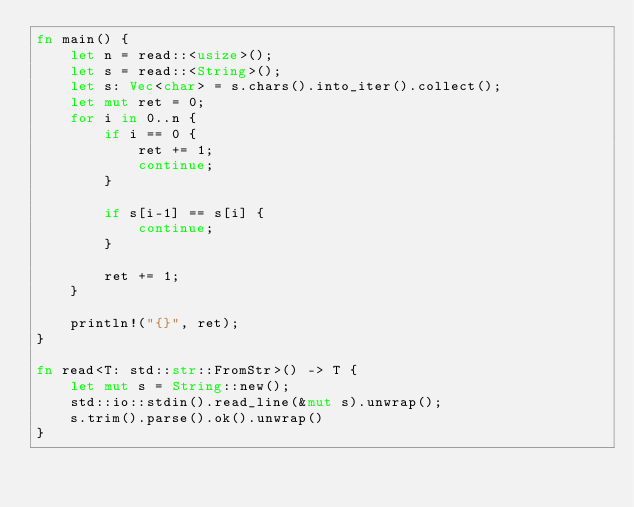<code> <loc_0><loc_0><loc_500><loc_500><_Rust_>fn main() {
    let n = read::<usize>();
    let s = read::<String>();
    let s: Vec<char> = s.chars().into_iter().collect();
    let mut ret = 0;
    for i in 0..n {
        if i == 0 {
            ret += 1;
            continue;
        }

        if s[i-1] == s[i] {
            continue;
        }

        ret += 1;
    }

    println!("{}", ret);
}

fn read<T: std::str::FromStr>() -> T {
    let mut s = String::new();
    std::io::stdin().read_line(&mut s).unwrap();
    s.trim().parse().ok().unwrap()
}

</code> 